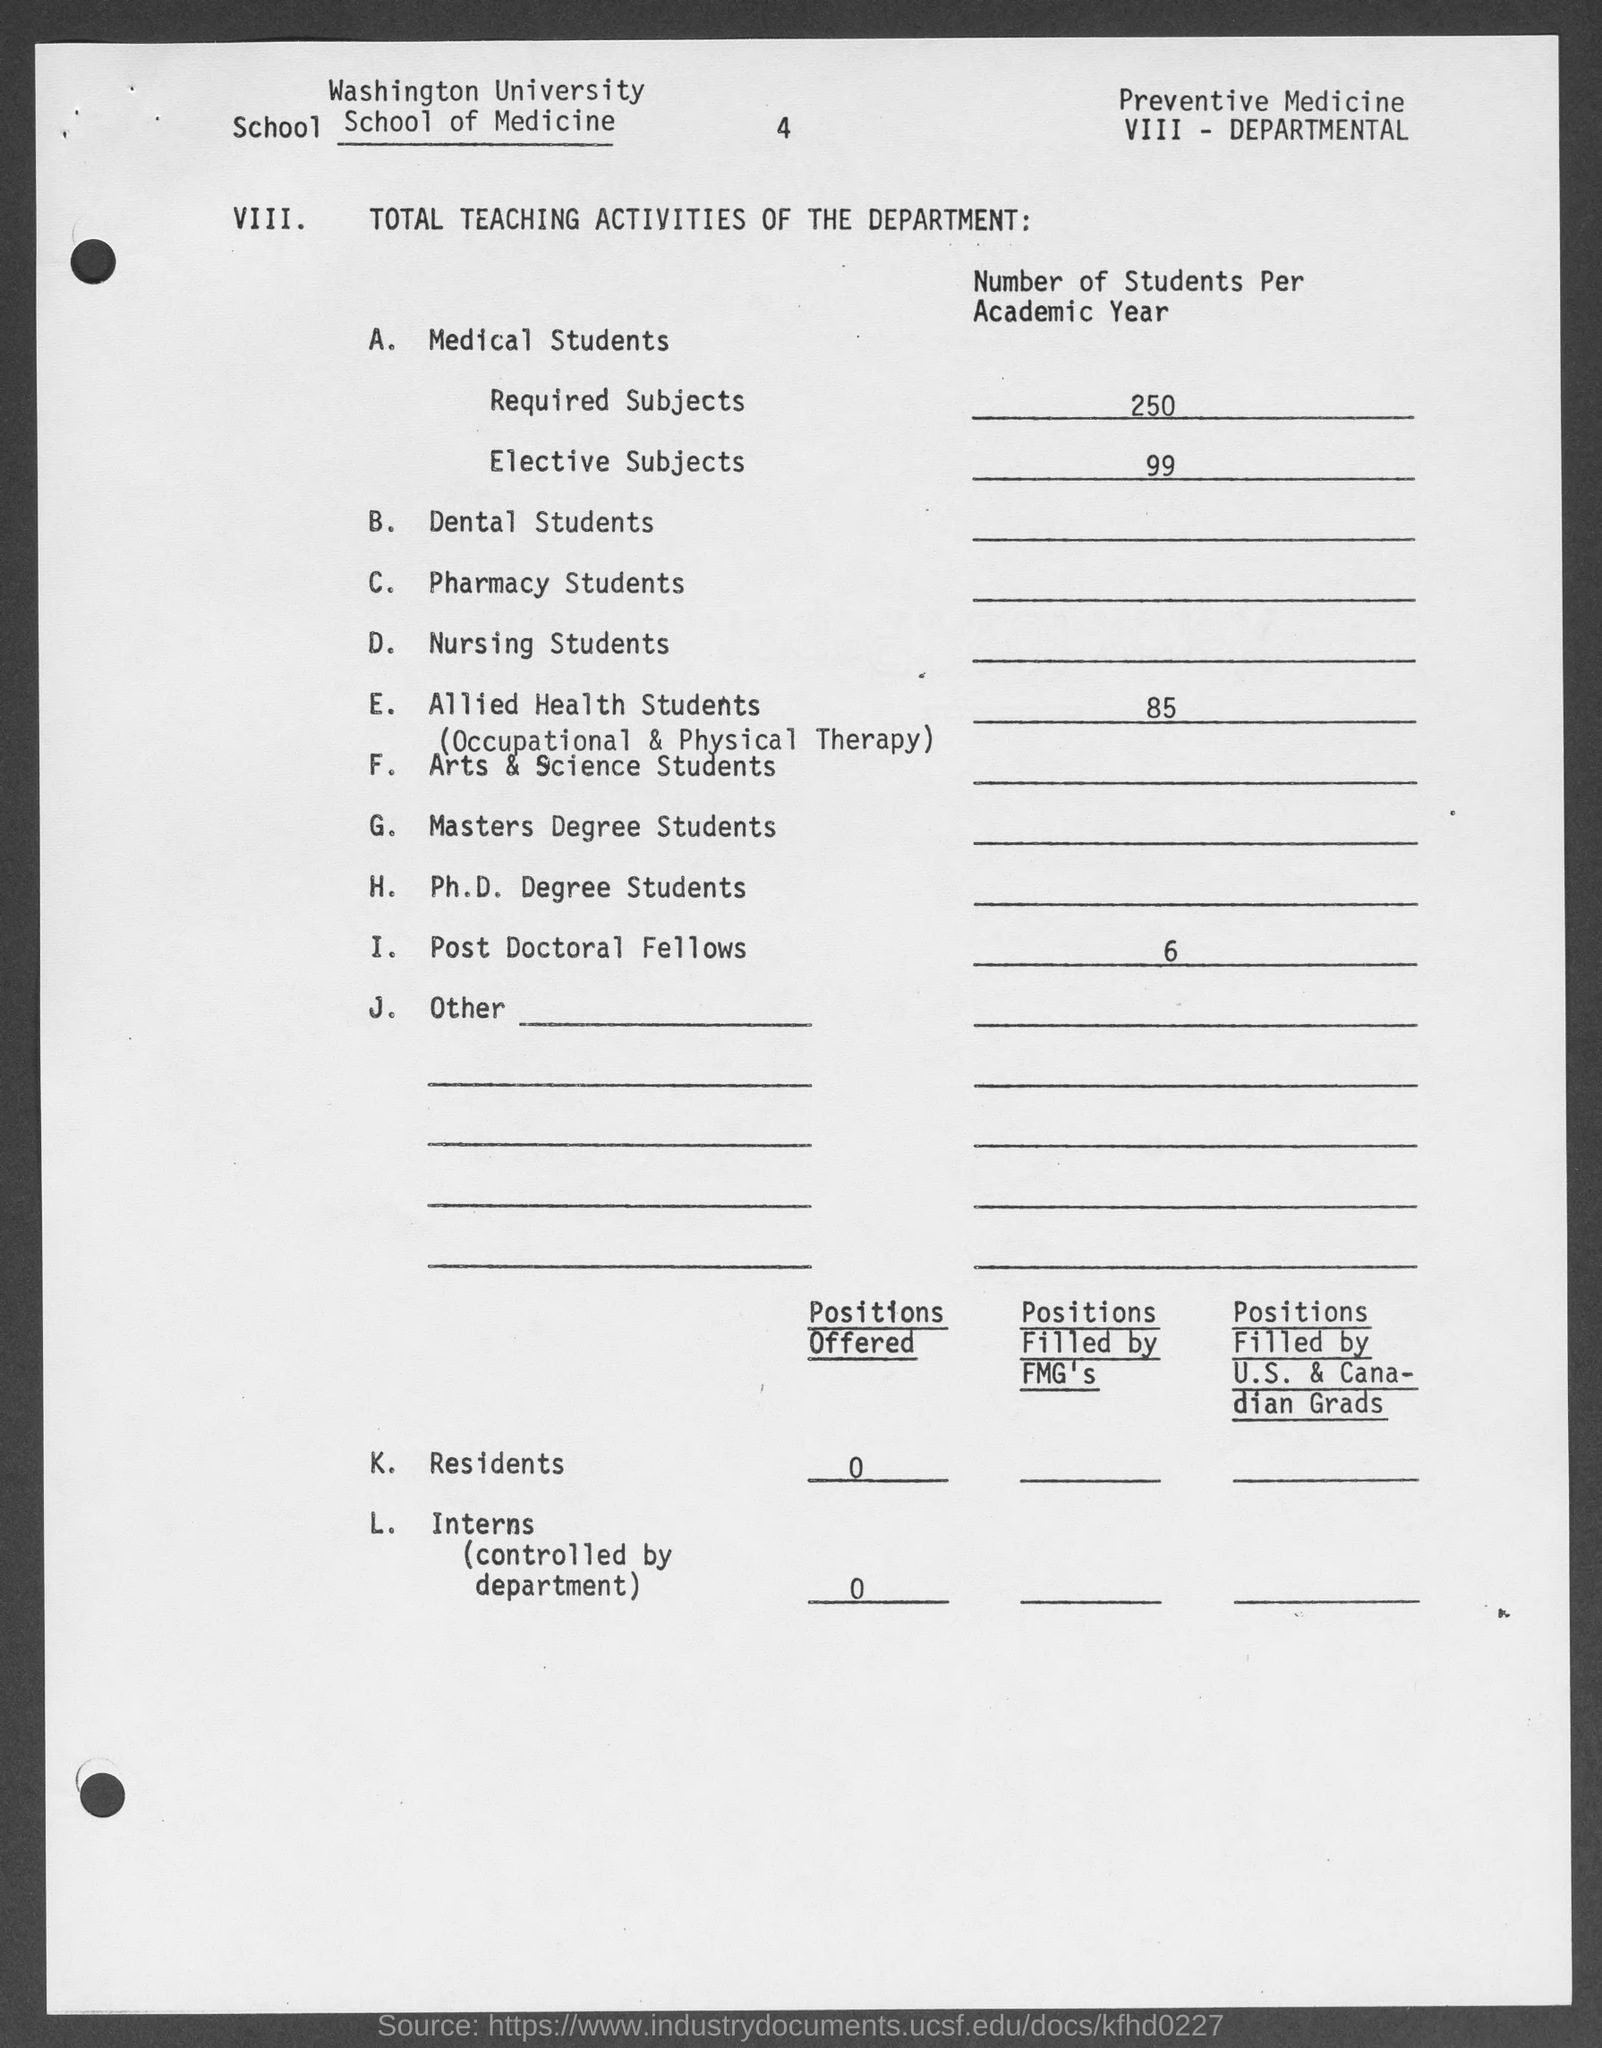What is the name of the university mentioned in the given form ?
Ensure brevity in your answer.  Washington University. What is value of required subjects for number of students per academic year as mentioned in the given form ?
Offer a terse response. 250. What is the value of elective subjects for number of students per academic year as mentioned in the given form ?
Provide a succinct answer. 99. How many number of positions offered by k. residents as mentioned in the given form ?
Ensure brevity in your answer.  0. 